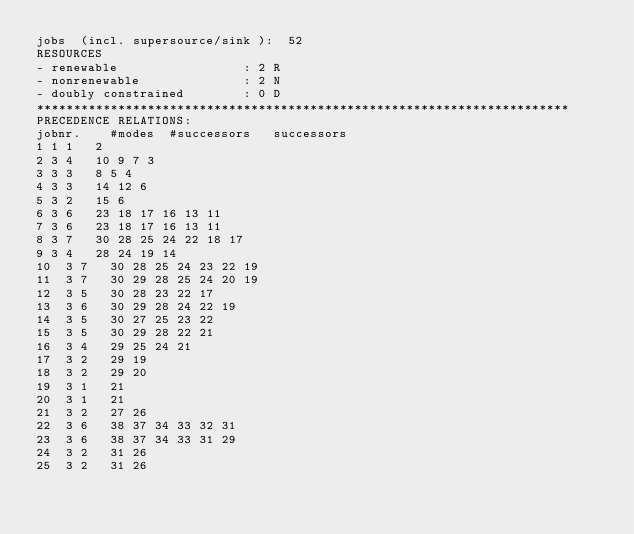Convert code to text. <code><loc_0><loc_0><loc_500><loc_500><_ObjectiveC_>jobs  (incl. supersource/sink ):	52
RESOURCES
- renewable                 : 2 R
- nonrenewable              : 2 N
- doubly constrained        : 0 D
************************************************************************
PRECEDENCE RELATIONS:
jobnr.    #modes  #successors   successors
1	1	1		2 
2	3	4		10 9 7 3 
3	3	3		8 5 4 
4	3	3		14 12 6 
5	3	2		15 6 
6	3	6		23 18 17 16 13 11 
7	3	6		23 18 17 16 13 11 
8	3	7		30 28 25 24 22 18 17 
9	3	4		28 24 19 14 
10	3	7		30 28 25 24 23 22 19 
11	3	7		30 29 28 25 24 20 19 
12	3	5		30 28 23 22 17 
13	3	6		30 29 28 24 22 19 
14	3	5		30 27 25 23 22 
15	3	5		30 29 28 22 21 
16	3	4		29 25 24 21 
17	3	2		29 19 
18	3	2		29 20 
19	3	1		21 
20	3	1		21 
21	3	2		27 26 
22	3	6		38 37 34 33 32 31 
23	3	6		38 37 34 33 31 29 
24	3	2		31 26 
25	3	2		31 26 </code> 